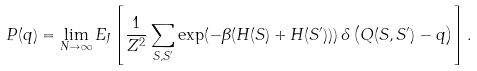<formula> <loc_0><loc_0><loc_500><loc_500>P ( q ) = \lim _ { N \to \infty } E _ { J } \left [ \frac { 1 } { Z ^ { 2 } } \sum _ { { S } , { S ^ { \prime } } } \exp ( - \beta ( H ( { S } ) + H ( { S ^ { \prime } } ) ) ) \, \delta \left ( Q ( { S } , { S ^ { \prime } } ) - q \right ) \right ] .</formula> 